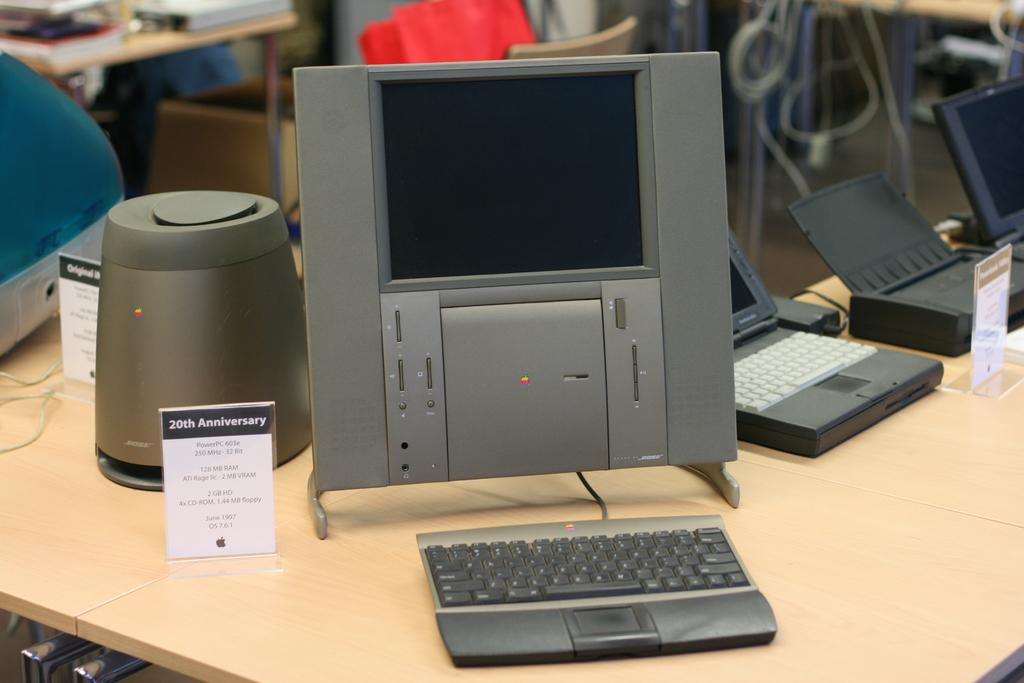What electronic devices can be seen in the image? There are laptops and a keyboard in the image. Where are these devices located? They are on a table in the image. What else can be seen in the background of the image? There is a chair, a box, wires, and a table with books in the background of the image. What type of tree is growing in the middle of the table in the image? There is no tree present in the image; it features electronic devices, a keyboard, and various items on a table and in the background. 